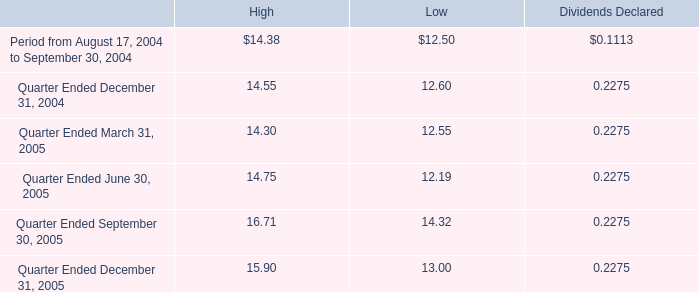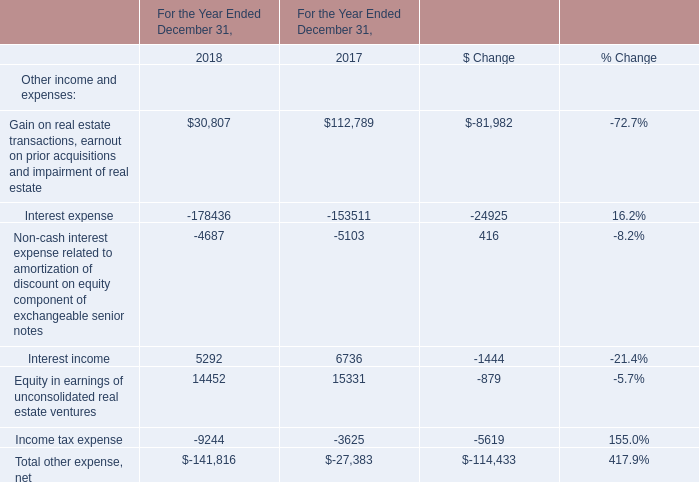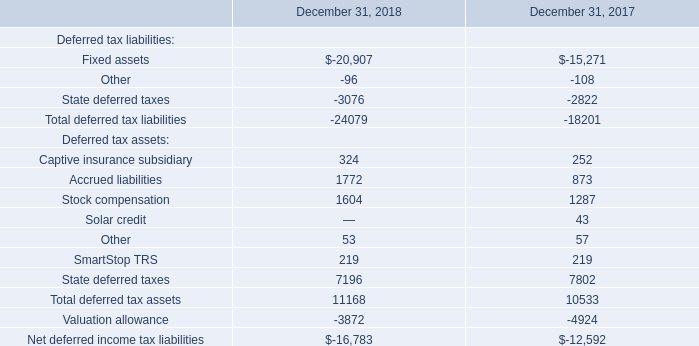What is the total amount of Interest income of For the Year Ended December 31, 2017, Fixed assets of December 31, 2018, and Income tax expense of For the Year Ended December 31, 2018 ? 
Computations: ((6736.0 + 20907.0) + 9244.0)
Answer: 36887.0. 